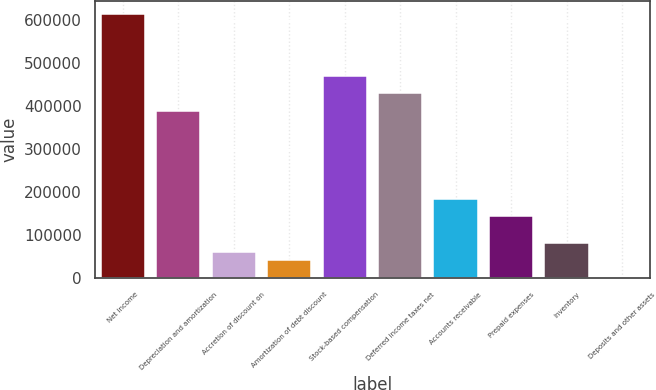<chart> <loc_0><loc_0><loc_500><loc_500><bar_chart><fcel>Net income<fcel>Depreciation and amortization<fcel>Accretion of discount on<fcel>Amortization of debt discount<fcel>Stock-based compensation<fcel>Deferred income taxes net<fcel>Accounts receivable<fcel>Prepaid expenses<fcel>Inventory<fcel>Deposits and other assets<nl><fcel>614606<fcel>389276<fcel>61524.5<fcel>41040<fcel>471214<fcel>430246<fcel>184432<fcel>143462<fcel>82009<fcel>71<nl></chart> 